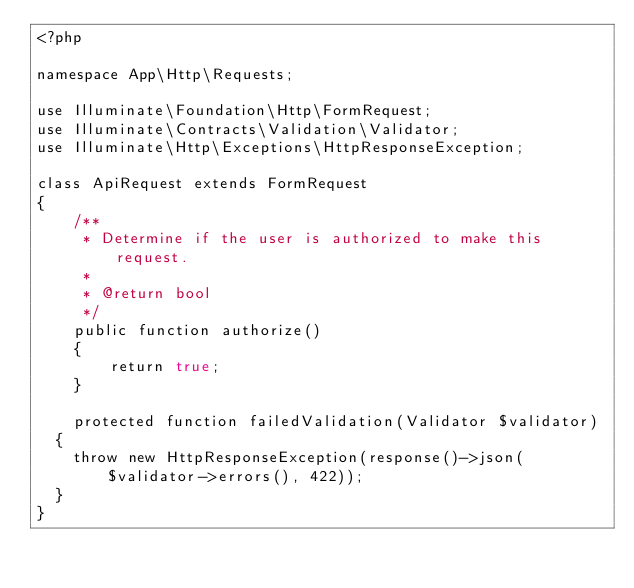<code> <loc_0><loc_0><loc_500><loc_500><_PHP_><?php

namespace App\Http\Requests;

use Illuminate\Foundation\Http\FormRequest;
use Illuminate\Contracts\Validation\Validator;
use Illuminate\Http\Exceptions\HttpResponseException;

class ApiRequest extends FormRequest
{
    /**
     * Determine if the user is authorized to make this request.
     *
     * @return bool
     */
    public function authorize()
    {
        return true;
    }

    protected function failedValidation(Validator $validator)
	{
		throw new HttpResponseException(response()->json($validator->errors(), 422));
	}
}
</code> 